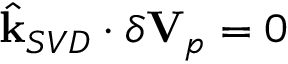<formula> <loc_0><loc_0><loc_500><loc_500>\hat { k } _ { S V D } \cdot \delta V _ { p } = 0</formula> 